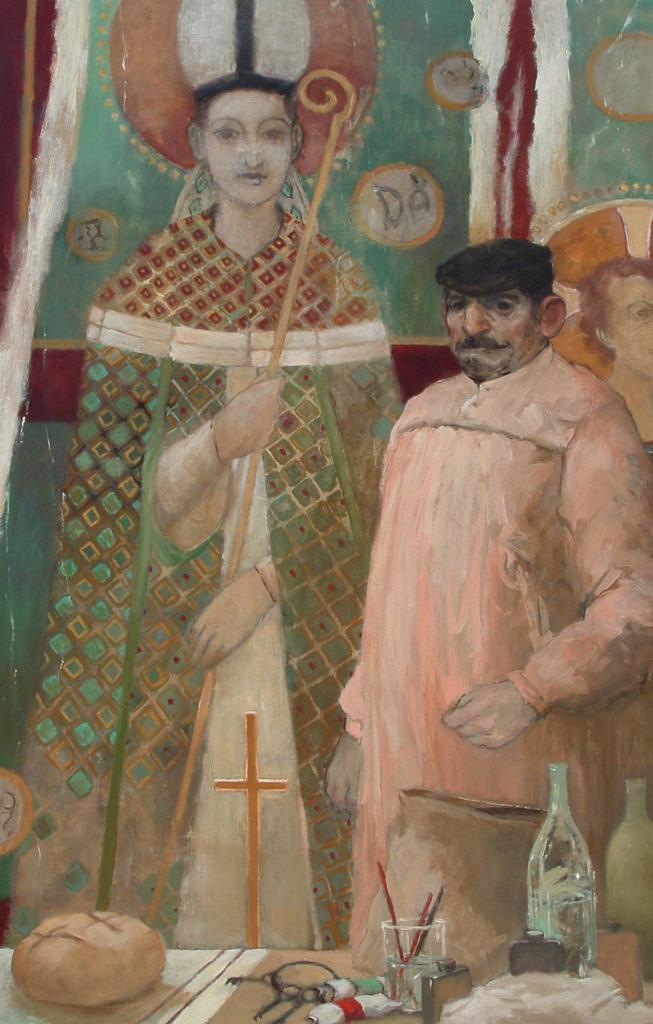Could you give a brief overview of what you see in this image? In the foreground of this image, there are paintings of two people and glass, bottles and few more objects on the table. 